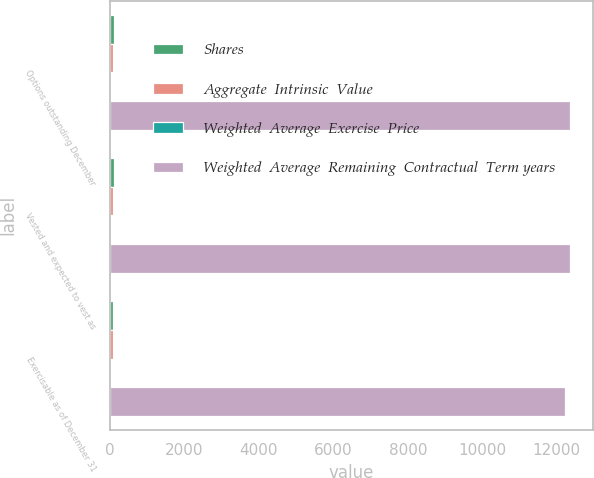Convert chart to OTSL. <chart><loc_0><loc_0><loc_500><loc_500><stacked_bar_chart><ecel><fcel>Options outstanding December<fcel>Vested and expected to vest as<fcel>Exercisable as of December 31<nl><fcel>Shares<fcel>91<fcel>91<fcel>90<nl><fcel>Aggregate  Intrinsic  Value<fcel>63.84<fcel>63.84<fcel>63.82<nl><fcel>Weighted  Average  Exercise  Price<fcel>4.9<fcel>4.9<fcel>4.9<nl><fcel>Weighted  Average  Remaining  Contractual  Term years<fcel>12360<fcel>12360<fcel>12227<nl></chart> 